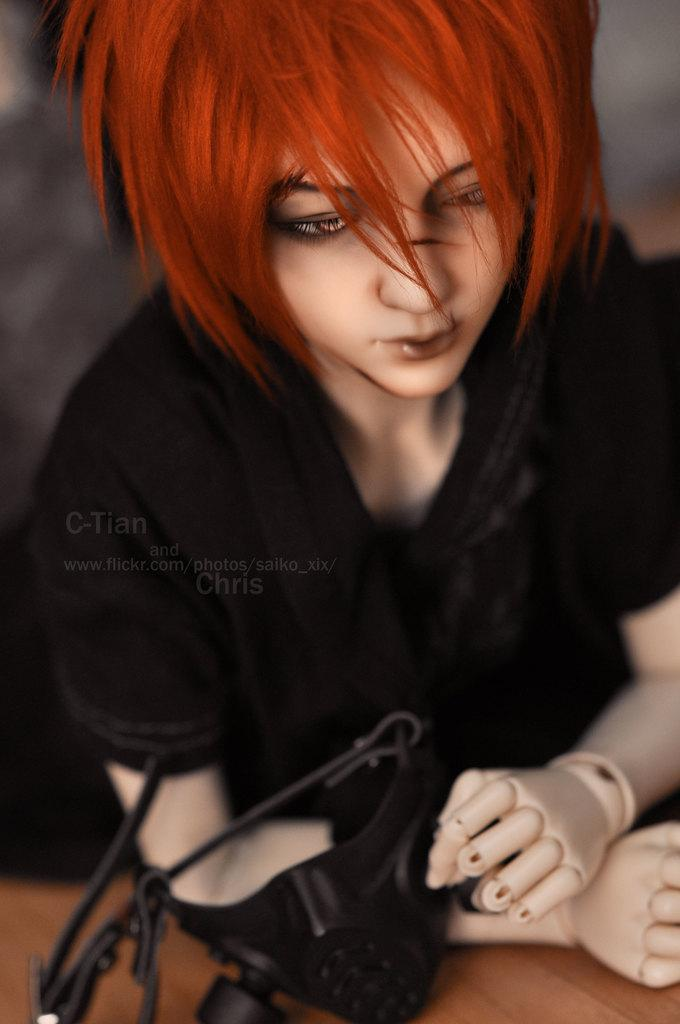What type of toy is present in the image? There is a human toy in the image. What is the human toy wearing? The human toy is wearing a black dress. What is the human toy holding? The human toy is holding a mask. What can be seen at the bottom of the image? There is a wooden object at the bottom of the image. How would you describe the background of the image? The background of the image has a blurred view. What type of rail can be seen in the image? There is no rail present in the image. What is the human toy's journey in the image? The image does not depict a journey; it is a still scene featuring a human toy and a wooden object. 